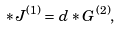Convert formula to latex. <formula><loc_0><loc_0><loc_500><loc_500>\ast { J } ^ { ( 1 ) } = d \ast { G } ^ { ( 2 ) } ,</formula> 